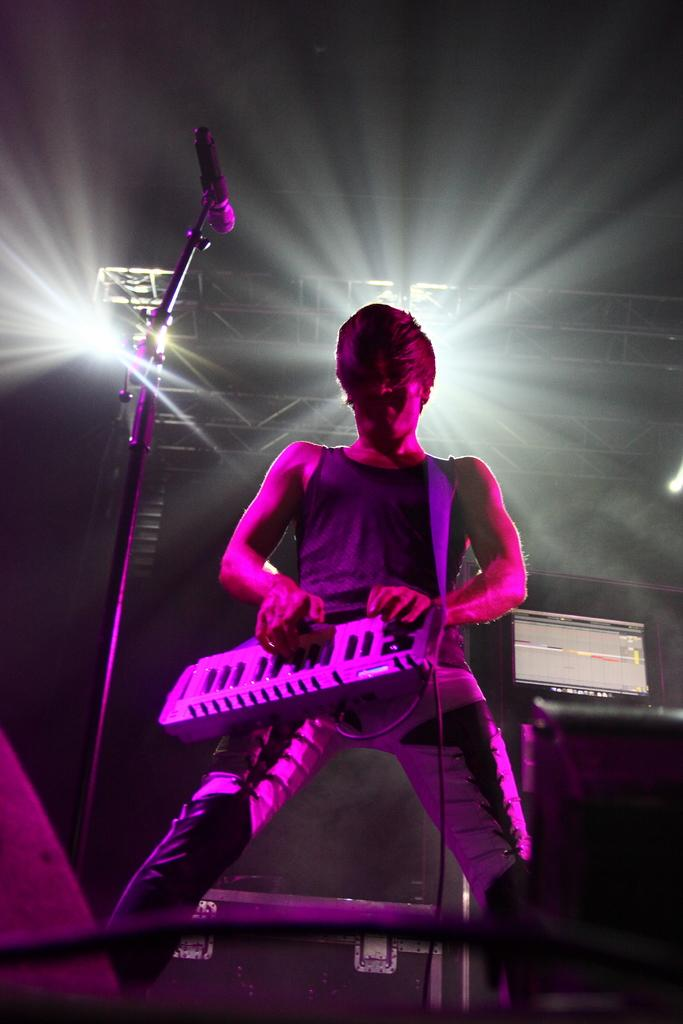What is the man in the image doing? The man is playing the piano. What object is located on the left side of the image? There is a microphone on the left side of the image. What can be seen in the background of the image? There are lights in the background of the image. How much payment is being made for the piano performance in the image? There is no indication of payment being made in the image. What type of wire is connected to the microphone in the image? There is no wire connected to the microphone visible in the image. 